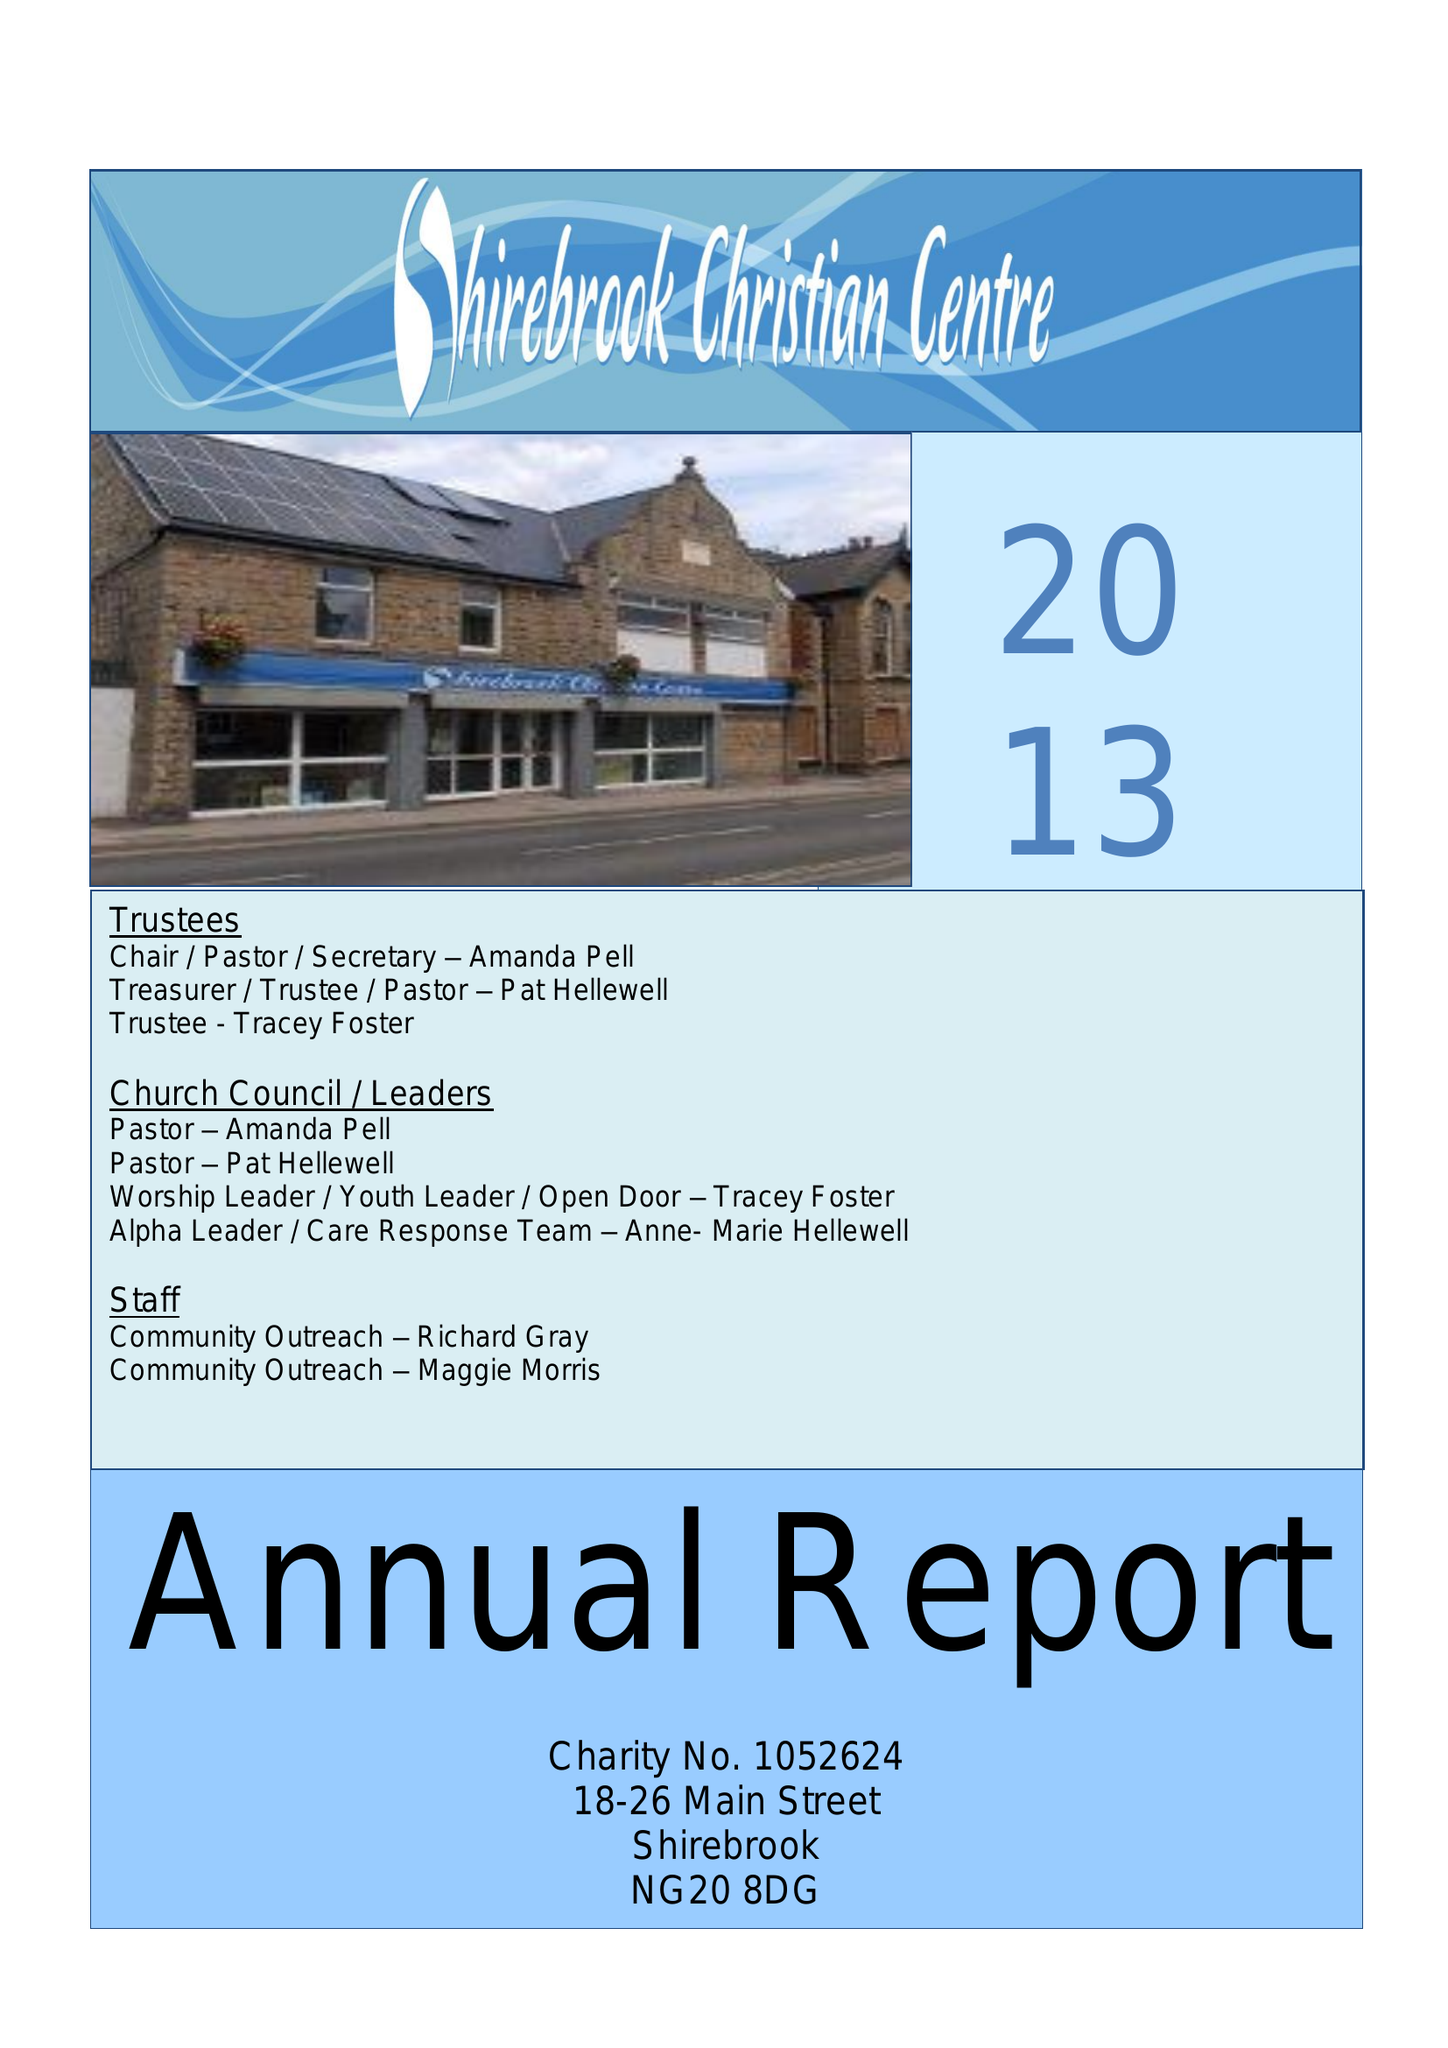What is the value for the report_date?
Answer the question using a single word or phrase. 2013-12-31 